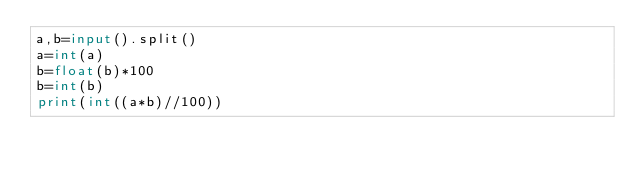Convert code to text. <code><loc_0><loc_0><loc_500><loc_500><_Python_>a,b=input().split()
a=int(a)
b=float(b)*100
b=int(b)
print(int((a*b)//100))</code> 